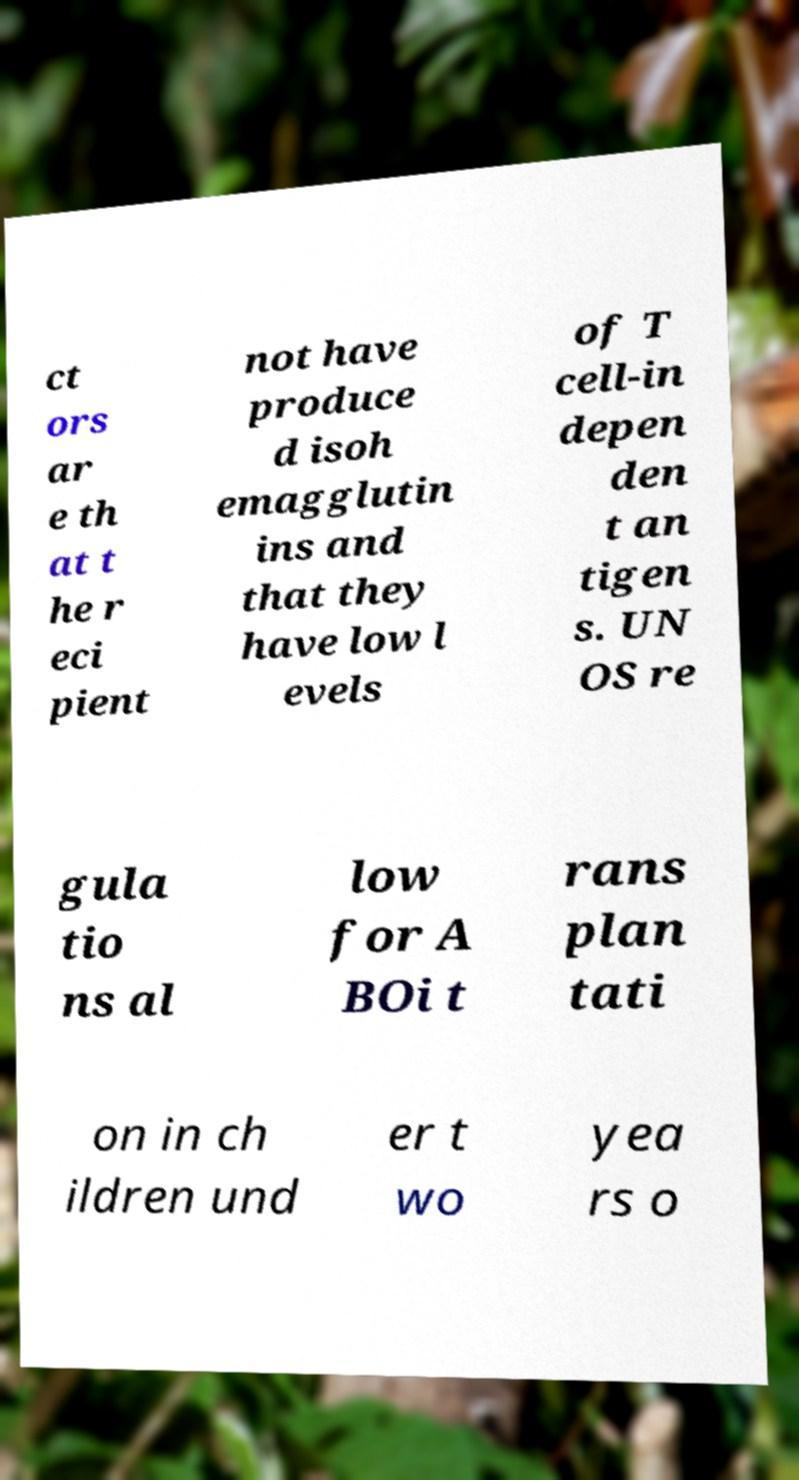I need the written content from this picture converted into text. Can you do that? ct ors ar e th at t he r eci pient not have produce d isoh emagglutin ins and that they have low l evels of T cell-in depen den t an tigen s. UN OS re gula tio ns al low for A BOi t rans plan tati on in ch ildren und er t wo yea rs o 